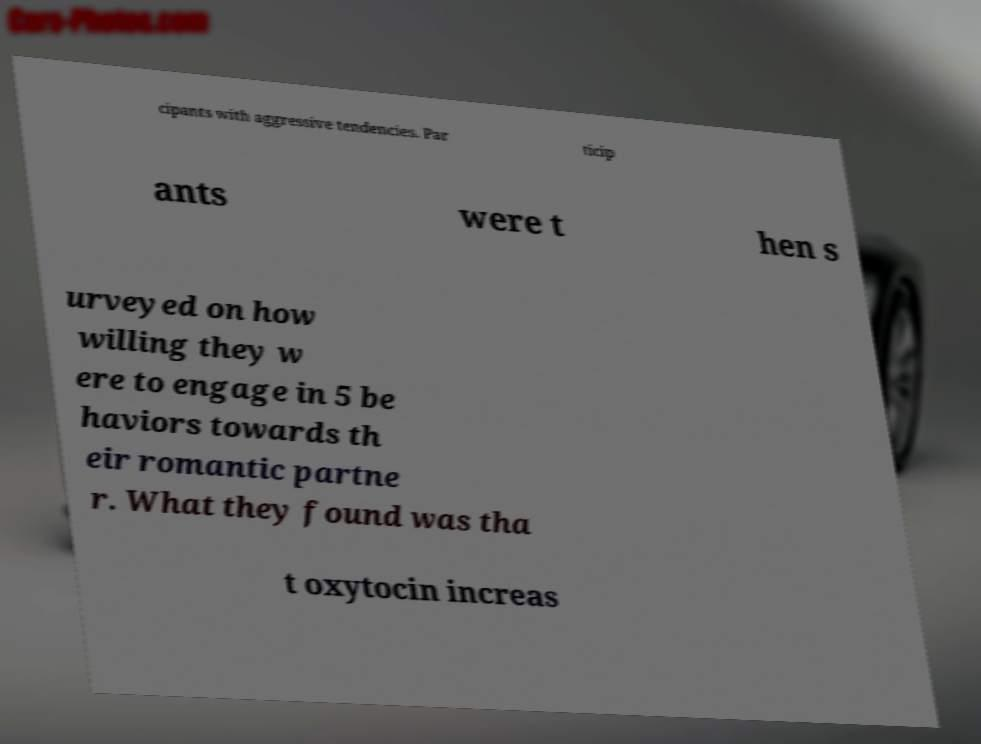Please read and relay the text visible in this image. What does it say? cipants with aggressive tendencies. Par ticip ants were t hen s urveyed on how willing they w ere to engage in 5 be haviors towards th eir romantic partne r. What they found was tha t oxytocin increas 